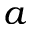Convert formula to latex. <formula><loc_0><loc_0><loc_500><loc_500>a</formula> 